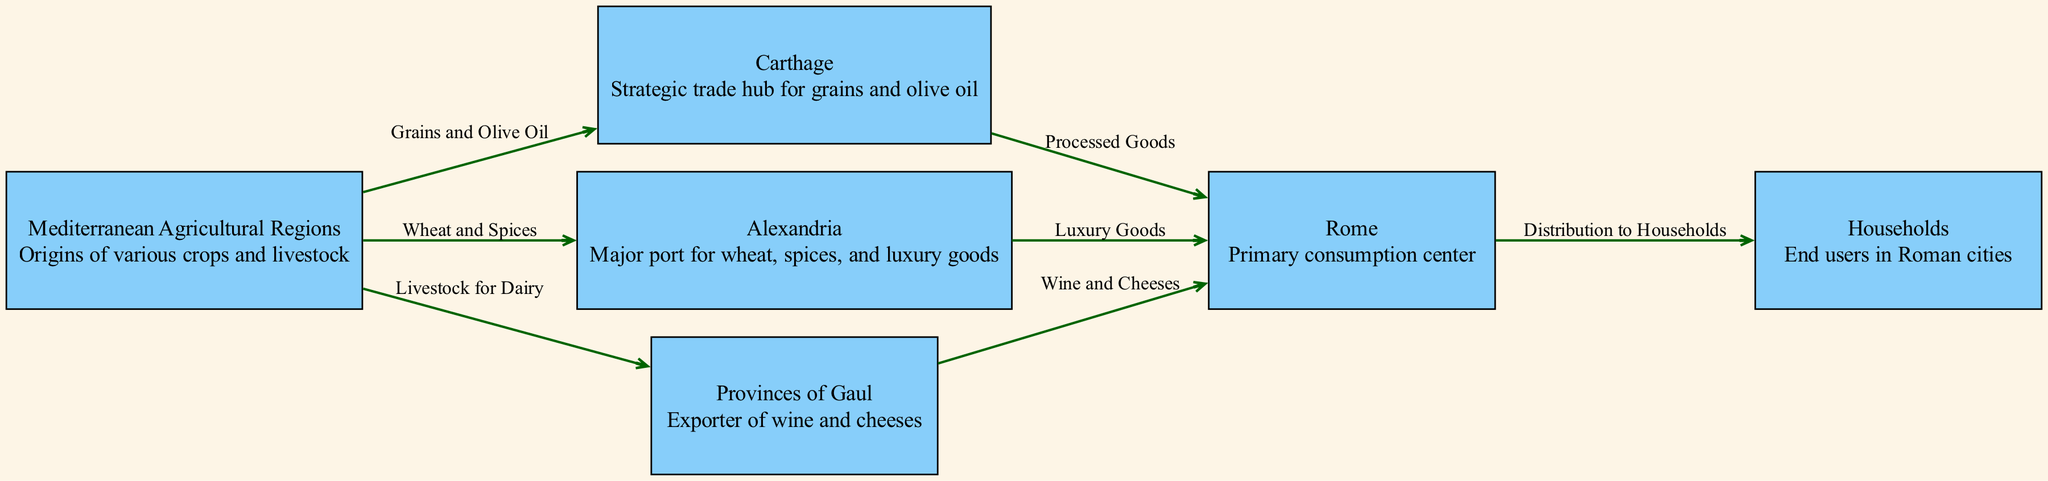What is the primary consumption center in the diagram? The diagram identifies "Rome" as the primary consumption center as indicated by its direct label.
Answer: Rome How many nodes are there in total? By counting the nodes listed in the diagram, there are six distinct nodes representing various locations in the trade route.
Answer: 6 Which agricultural product is linked to both Carthage and Rome? The edge labeled "Processed Goods" connects "Carthage" to "Rome", indicating that agricultural products from Carthage are dealt with at the consumption center.
Answer: Processed Goods What is the key product exported from the provinces of Gaul? According to the diagram, "Wine and Cheeses" are the primary exports from the "Provinces of Gaul" to "Rome", highlighted in the relevant edge.
Answer: Wine and Cheeses Which node represents a major port for luxury goods? "Alexandria" is specified in the diagram as a major port, particularly for luxury goods, as noted in its description.
Answer: Alexandria What connects the Mediterranean Agricultural Regions to Carthage? The edge labeled "Grains and Olive Oil" illustrates the direct connection and flow of these products from "Mediterranean Agricultural Regions" to "Carthage".
Answer: Grains and Olive Oil How many edges are outlined between the nodes? The diagram displays a total of six edges that represent the connections and trade flow between the different nodes.
Answer: 6 Which node is the end user in Roman cities? The diagram points to "Households" as the ultimate consumers for the goods, designated in the last step of the distribution process.
Answer: Households What is transported from Alexandria to Rome? The edge labeled "Luxury Goods" represents the transport of these goods from "Alexandria" to "Rome", connecting both nodes in the trade route.
Answer: Luxury Goods 